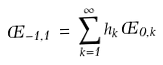Convert formula to latex. <formula><loc_0><loc_0><loc_500><loc_500>\phi _ { - 1 , 1 } \, = \, \sum _ { k = 1 } ^ { \infty } h _ { k } \, \phi _ { 0 , k }</formula> 